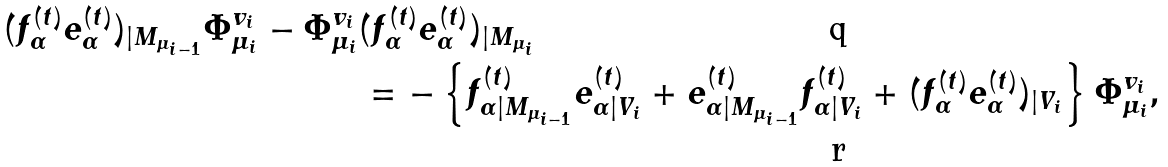Convert formula to latex. <formula><loc_0><loc_0><loc_500><loc_500>( f ^ { ( t ) } _ { \alpha } e ^ { ( t ) } _ { \alpha } ) _ { | M _ { \mu _ { i - 1 } } } \Phi ^ { v _ { i } } _ { \mu _ { i } } - \Phi ^ { v _ { i } } _ { \mu _ { i } } & ( f ^ { ( t ) } _ { \alpha } e ^ { ( t ) } _ { \alpha } ) _ { | M _ { \mu _ { i } } } \\ & = - \left \{ f ^ { ( t ) } _ { \alpha | M _ { \mu _ { i - 1 } } } e ^ { ( t ) } _ { \alpha | V _ { i } } + e ^ { ( t ) } _ { \alpha | M _ { \mu _ { i - 1 } } } f ^ { ( t ) } _ { \alpha | V _ { i } } + ( f ^ { ( t ) } _ { \alpha } e ^ { ( t ) } _ { \alpha } ) _ { | V _ { i } } \right \} \Phi ^ { v _ { i } } _ { \mu _ { i } } ,</formula> 